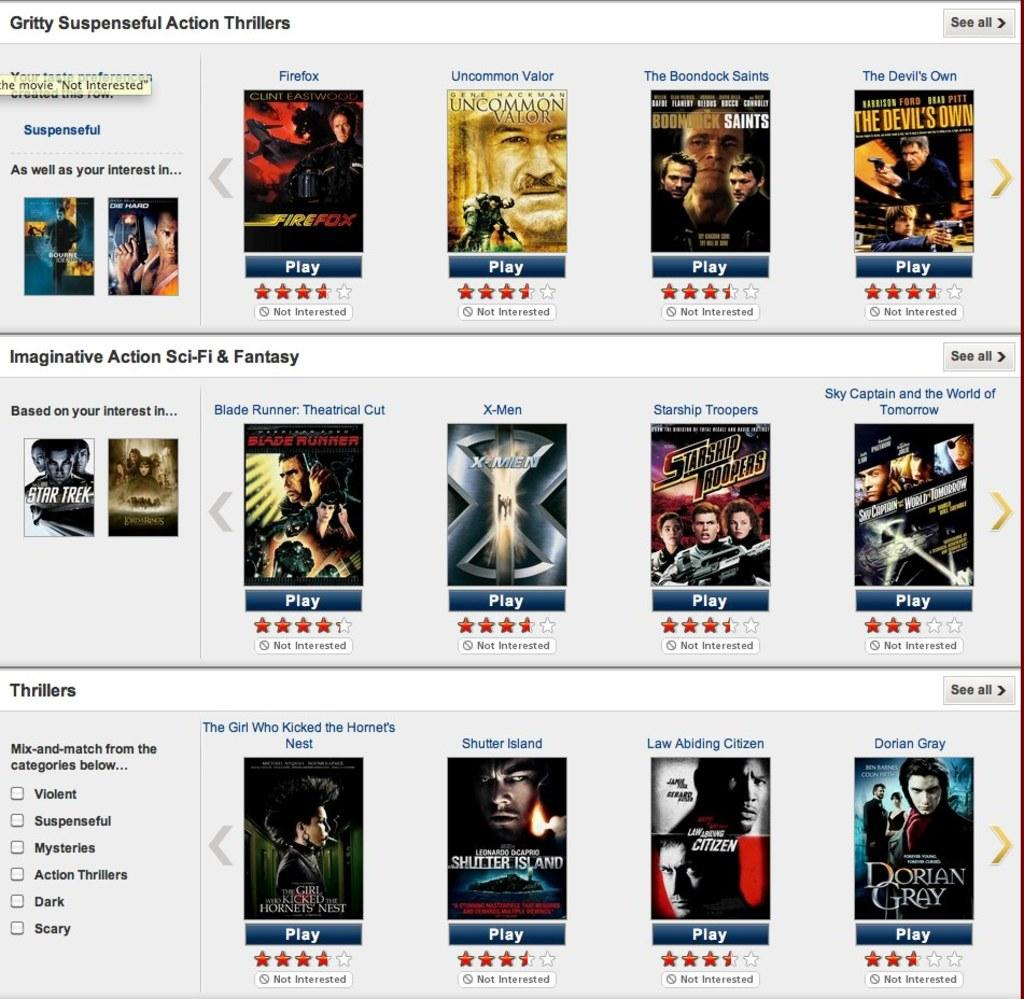<image>
Provide a brief description of the given image. A screen shot of many movie title such as The Devil's Own. 